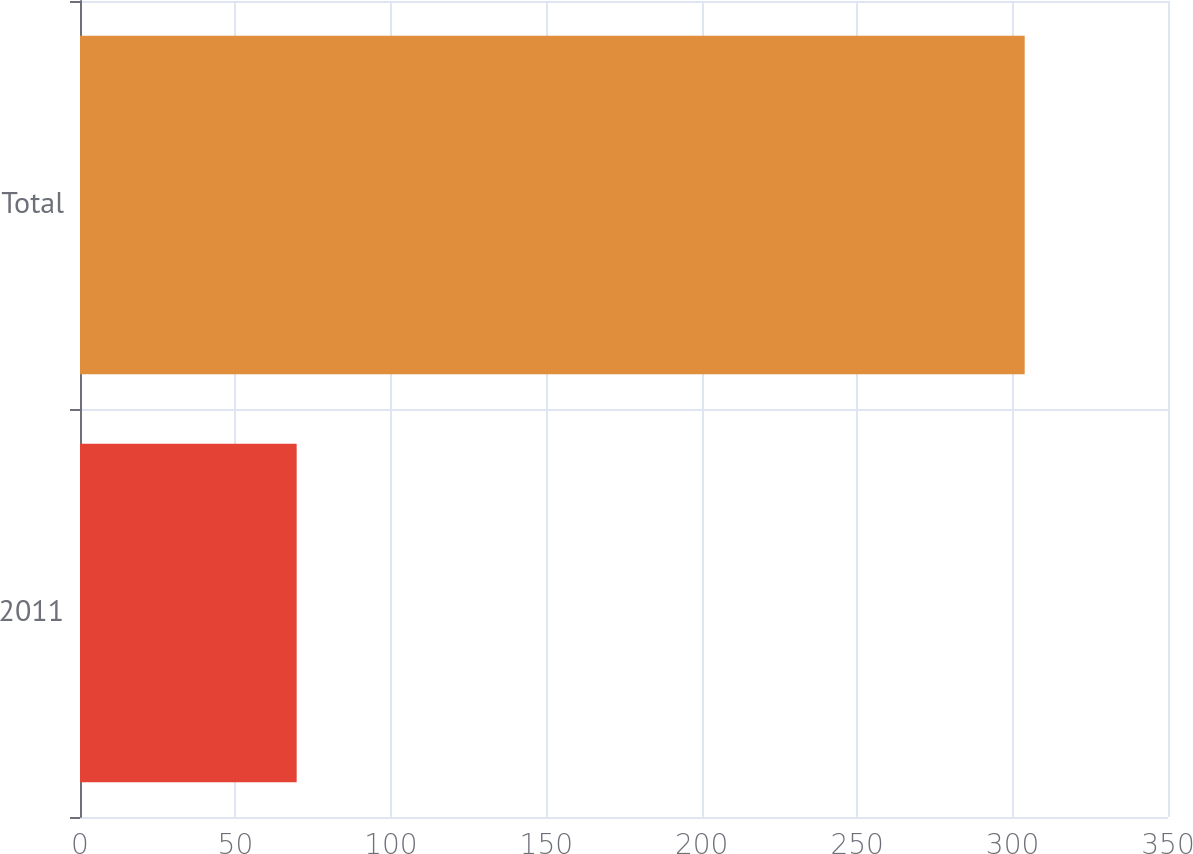<chart> <loc_0><loc_0><loc_500><loc_500><bar_chart><fcel>2011<fcel>Total<nl><fcel>69.7<fcel>303.9<nl></chart> 